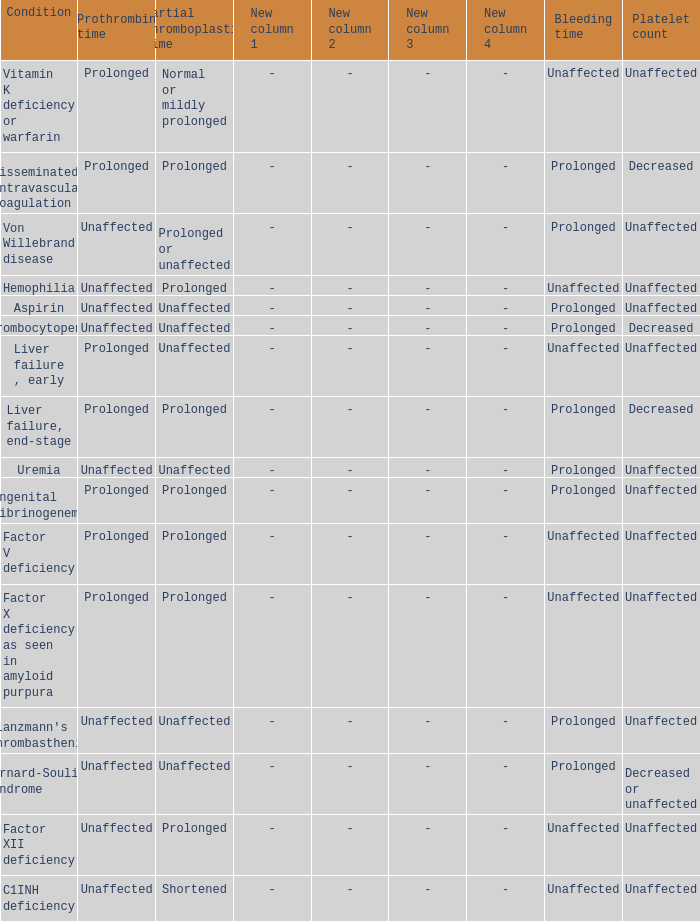Which Bleeding time has a Condition of factor x deficiency as seen in amyloid purpura? Unaffected. 